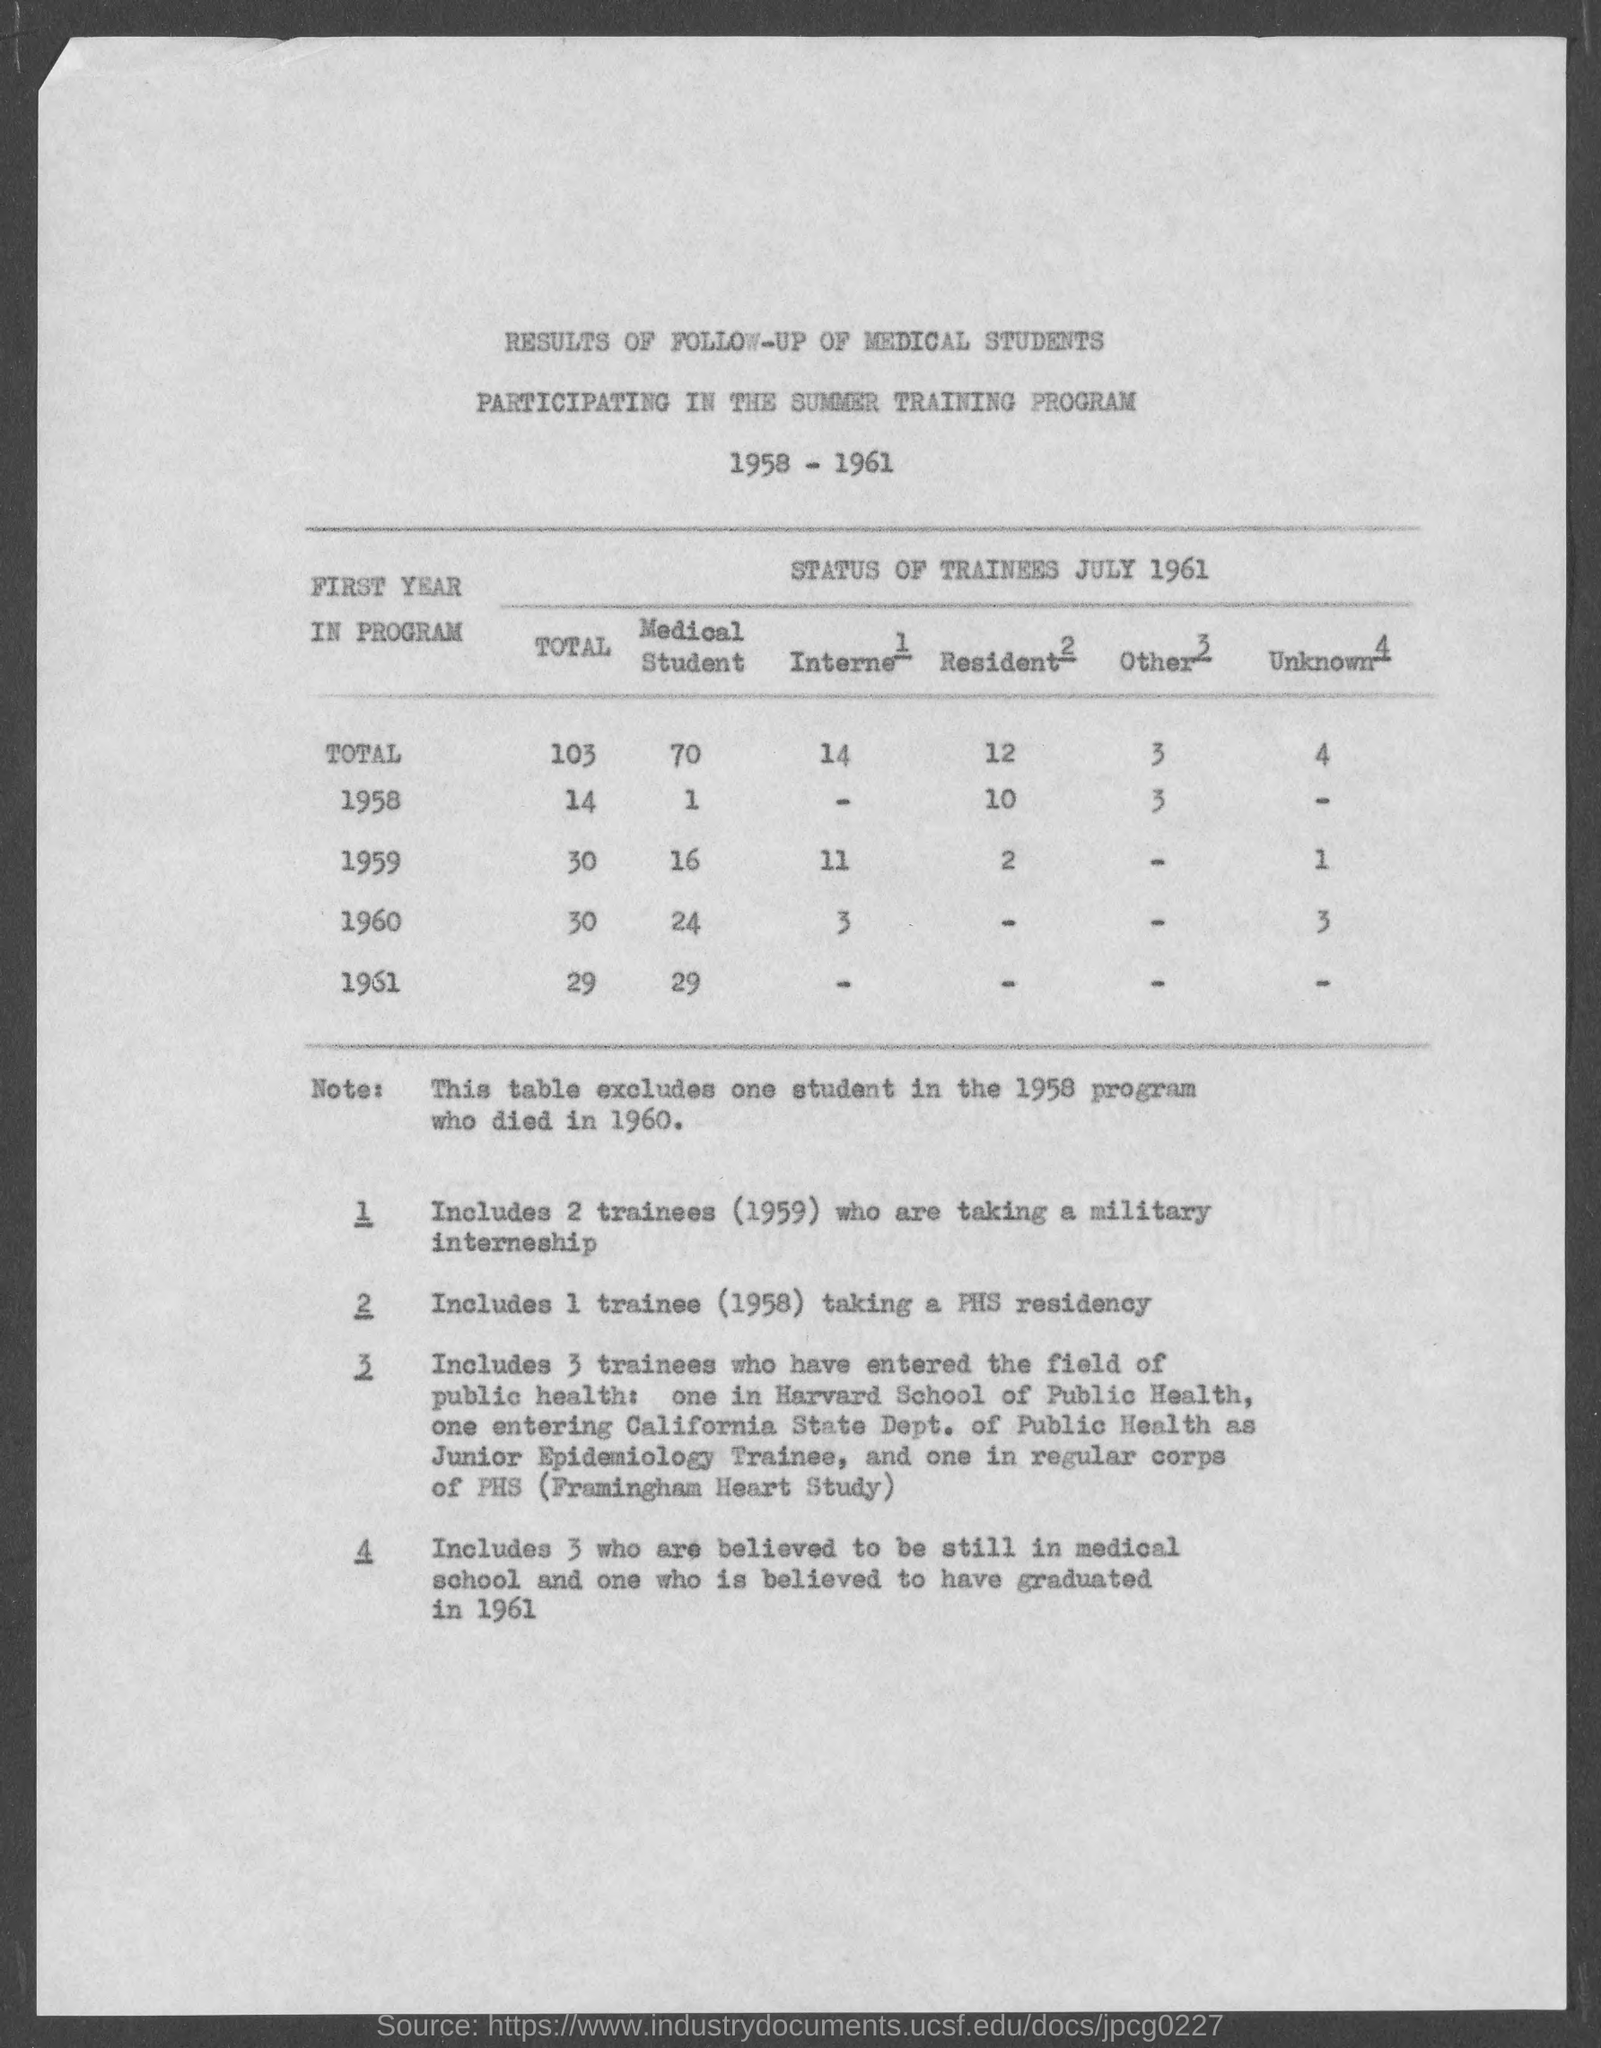Give some essential details in this illustration. In 1960, there were 24 medical students. In 1960, the number of internets was three. According to records from 1958, there were a specific number of medical students enrolled during that year. In 1959, the number of residents was two. The total for interns is 14. 